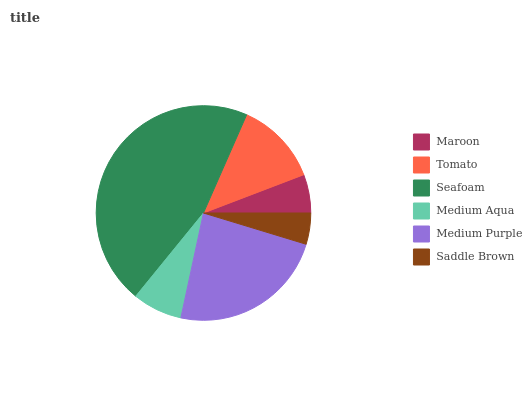Is Saddle Brown the minimum?
Answer yes or no. Yes. Is Seafoam the maximum?
Answer yes or no. Yes. Is Tomato the minimum?
Answer yes or no. No. Is Tomato the maximum?
Answer yes or no. No. Is Tomato greater than Maroon?
Answer yes or no. Yes. Is Maroon less than Tomato?
Answer yes or no. Yes. Is Maroon greater than Tomato?
Answer yes or no. No. Is Tomato less than Maroon?
Answer yes or no. No. Is Tomato the high median?
Answer yes or no. Yes. Is Medium Aqua the low median?
Answer yes or no. Yes. Is Medium Purple the high median?
Answer yes or no. No. Is Maroon the low median?
Answer yes or no. No. 